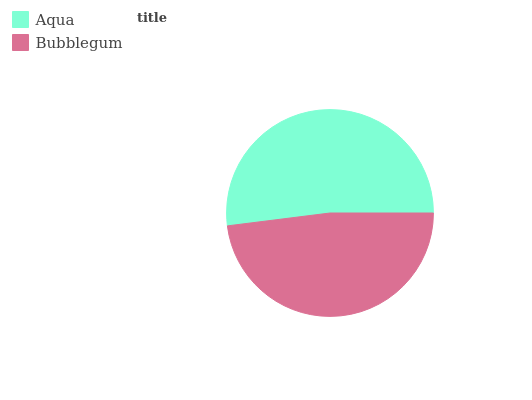Is Bubblegum the minimum?
Answer yes or no. Yes. Is Aqua the maximum?
Answer yes or no. Yes. Is Bubblegum the maximum?
Answer yes or no. No. Is Aqua greater than Bubblegum?
Answer yes or no. Yes. Is Bubblegum less than Aqua?
Answer yes or no. Yes. Is Bubblegum greater than Aqua?
Answer yes or no. No. Is Aqua less than Bubblegum?
Answer yes or no. No. Is Aqua the high median?
Answer yes or no. Yes. Is Bubblegum the low median?
Answer yes or no. Yes. Is Bubblegum the high median?
Answer yes or no. No. Is Aqua the low median?
Answer yes or no. No. 